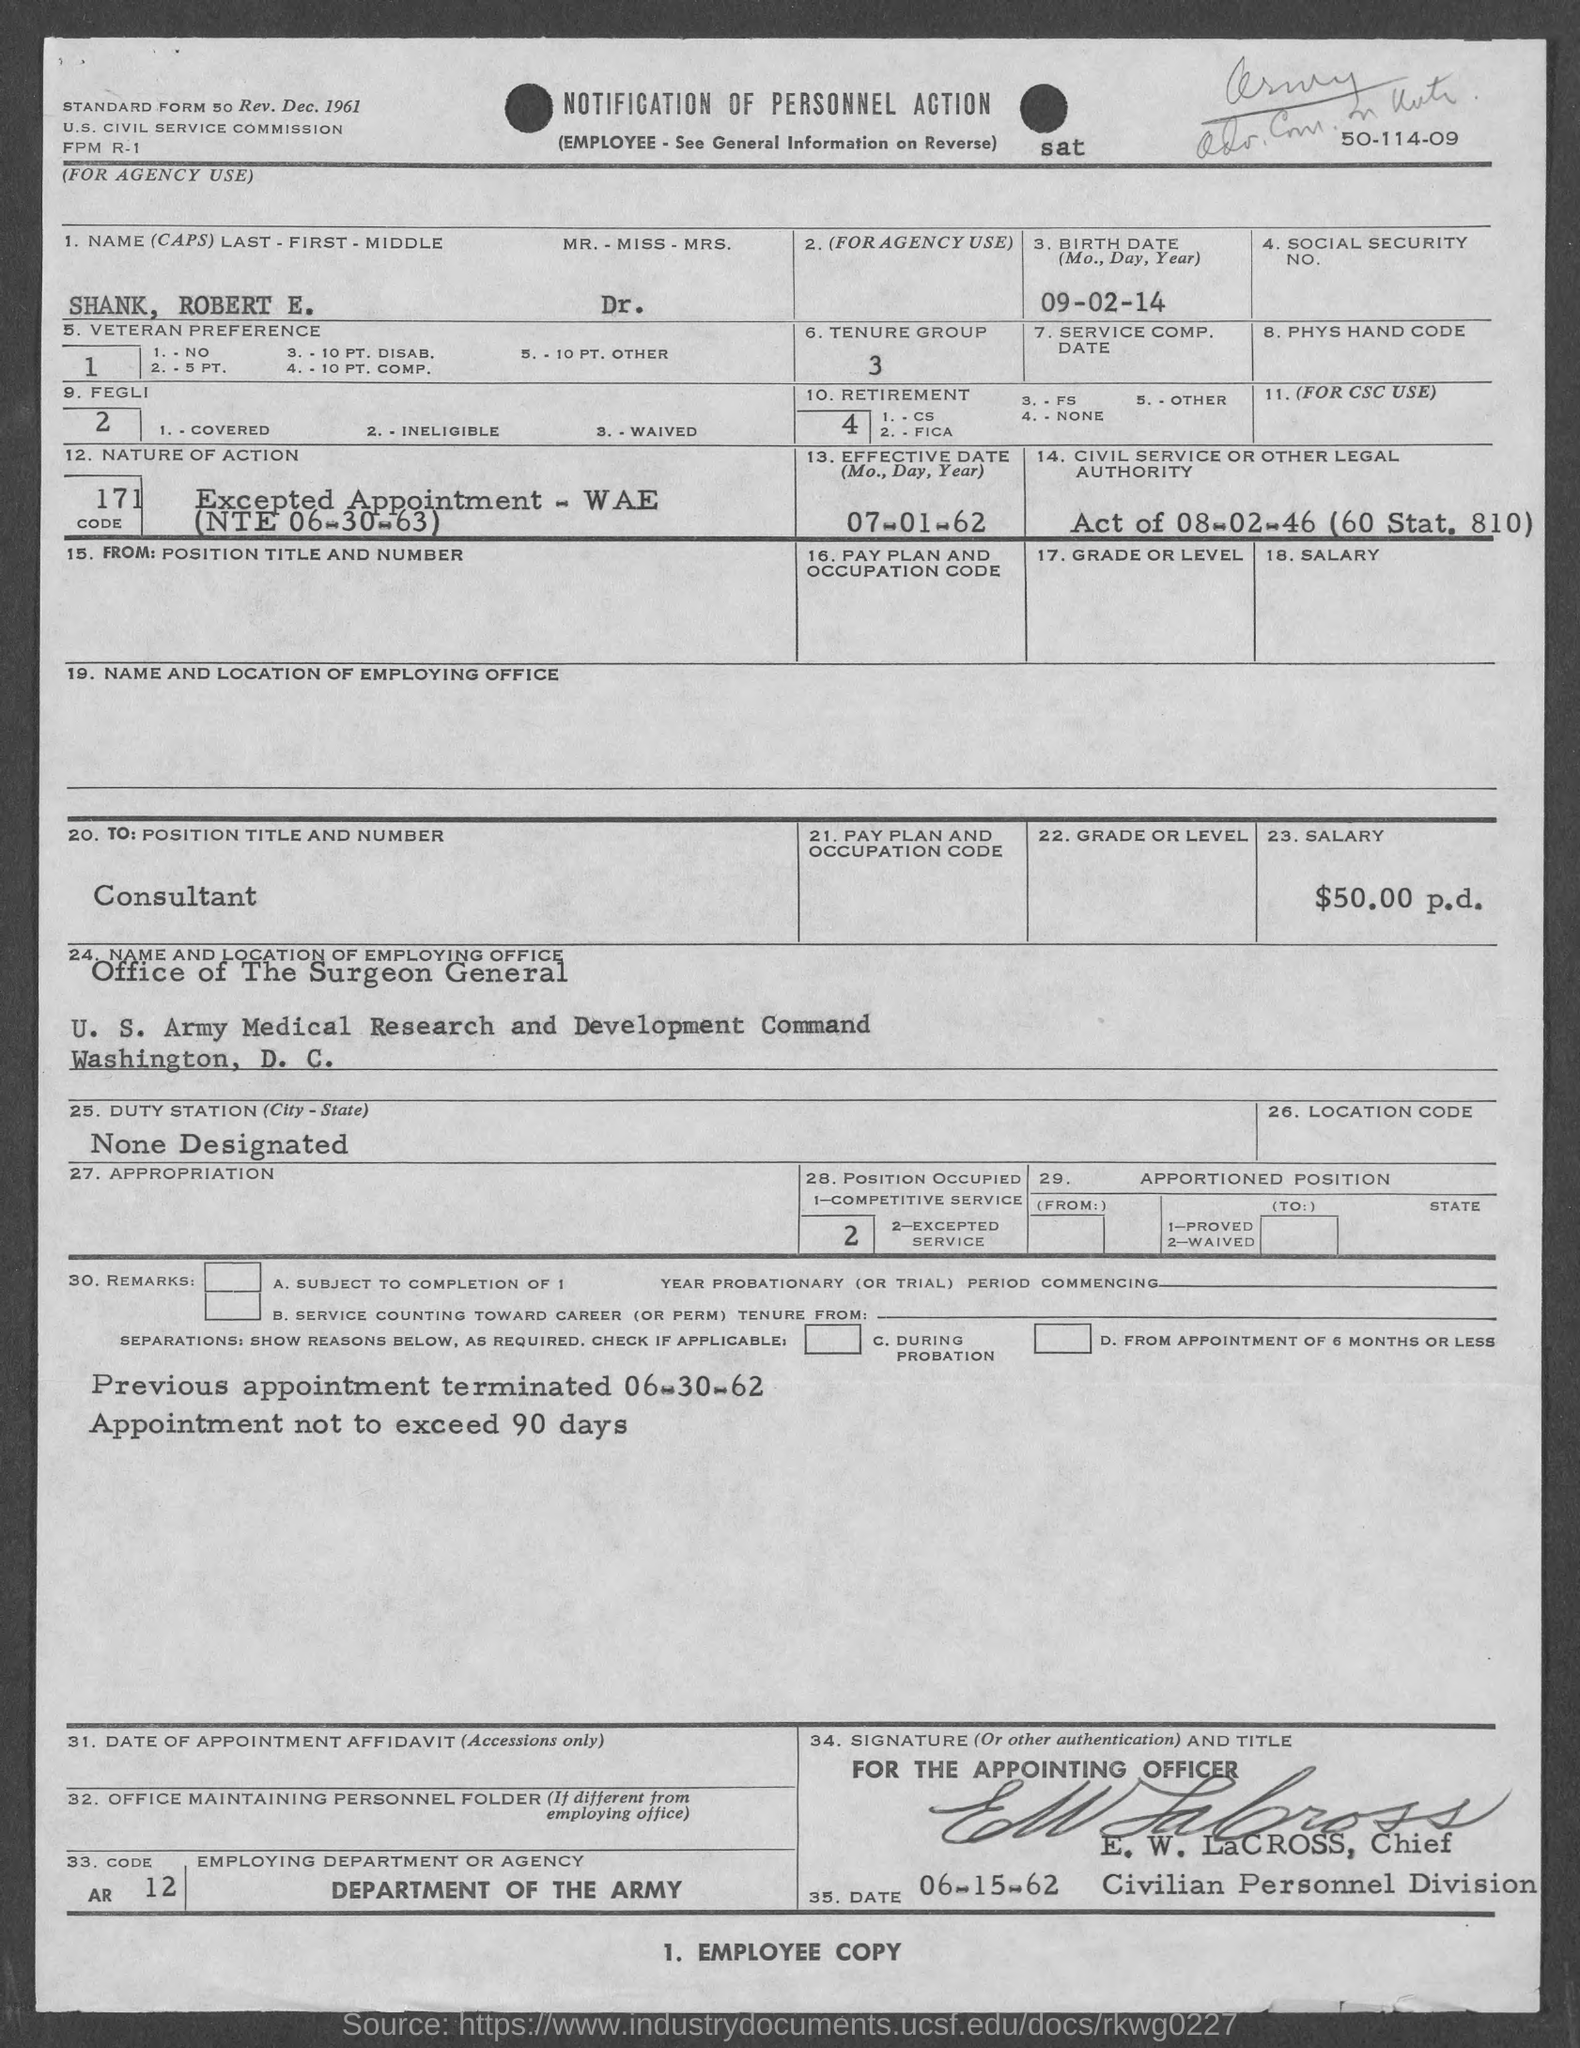What is the name of person in the form?
Make the answer very short. Shank, Robert E. DR. What is the tenure group?
Offer a very short reply. 3. What is the birth date of shank, robert e.?
Offer a very short reply. 09-02-14. What is the effective date?
Provide a short and direct response. 07-01-62. What is the employing department or agency ?
Your answer should be very brief. Department of the Army. What is position of e.w. lacross ?
Provide a short and direct response. Chief. 